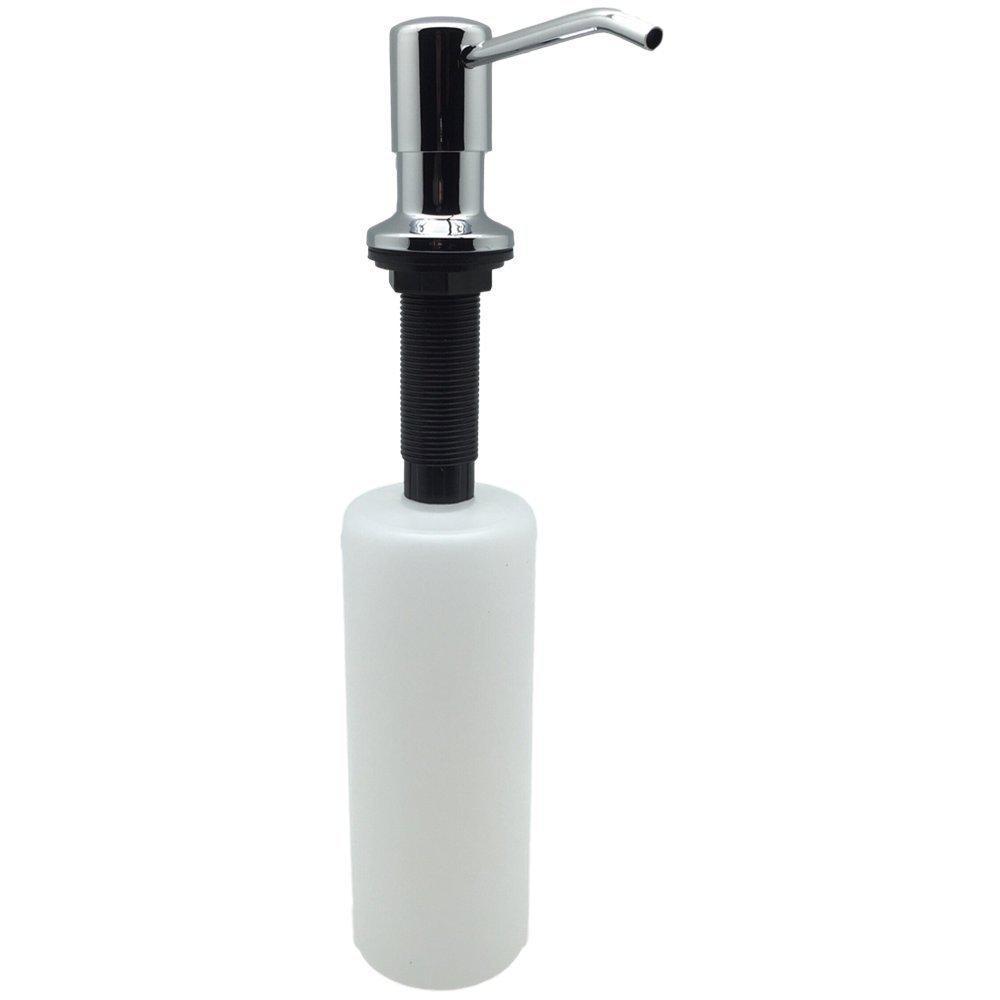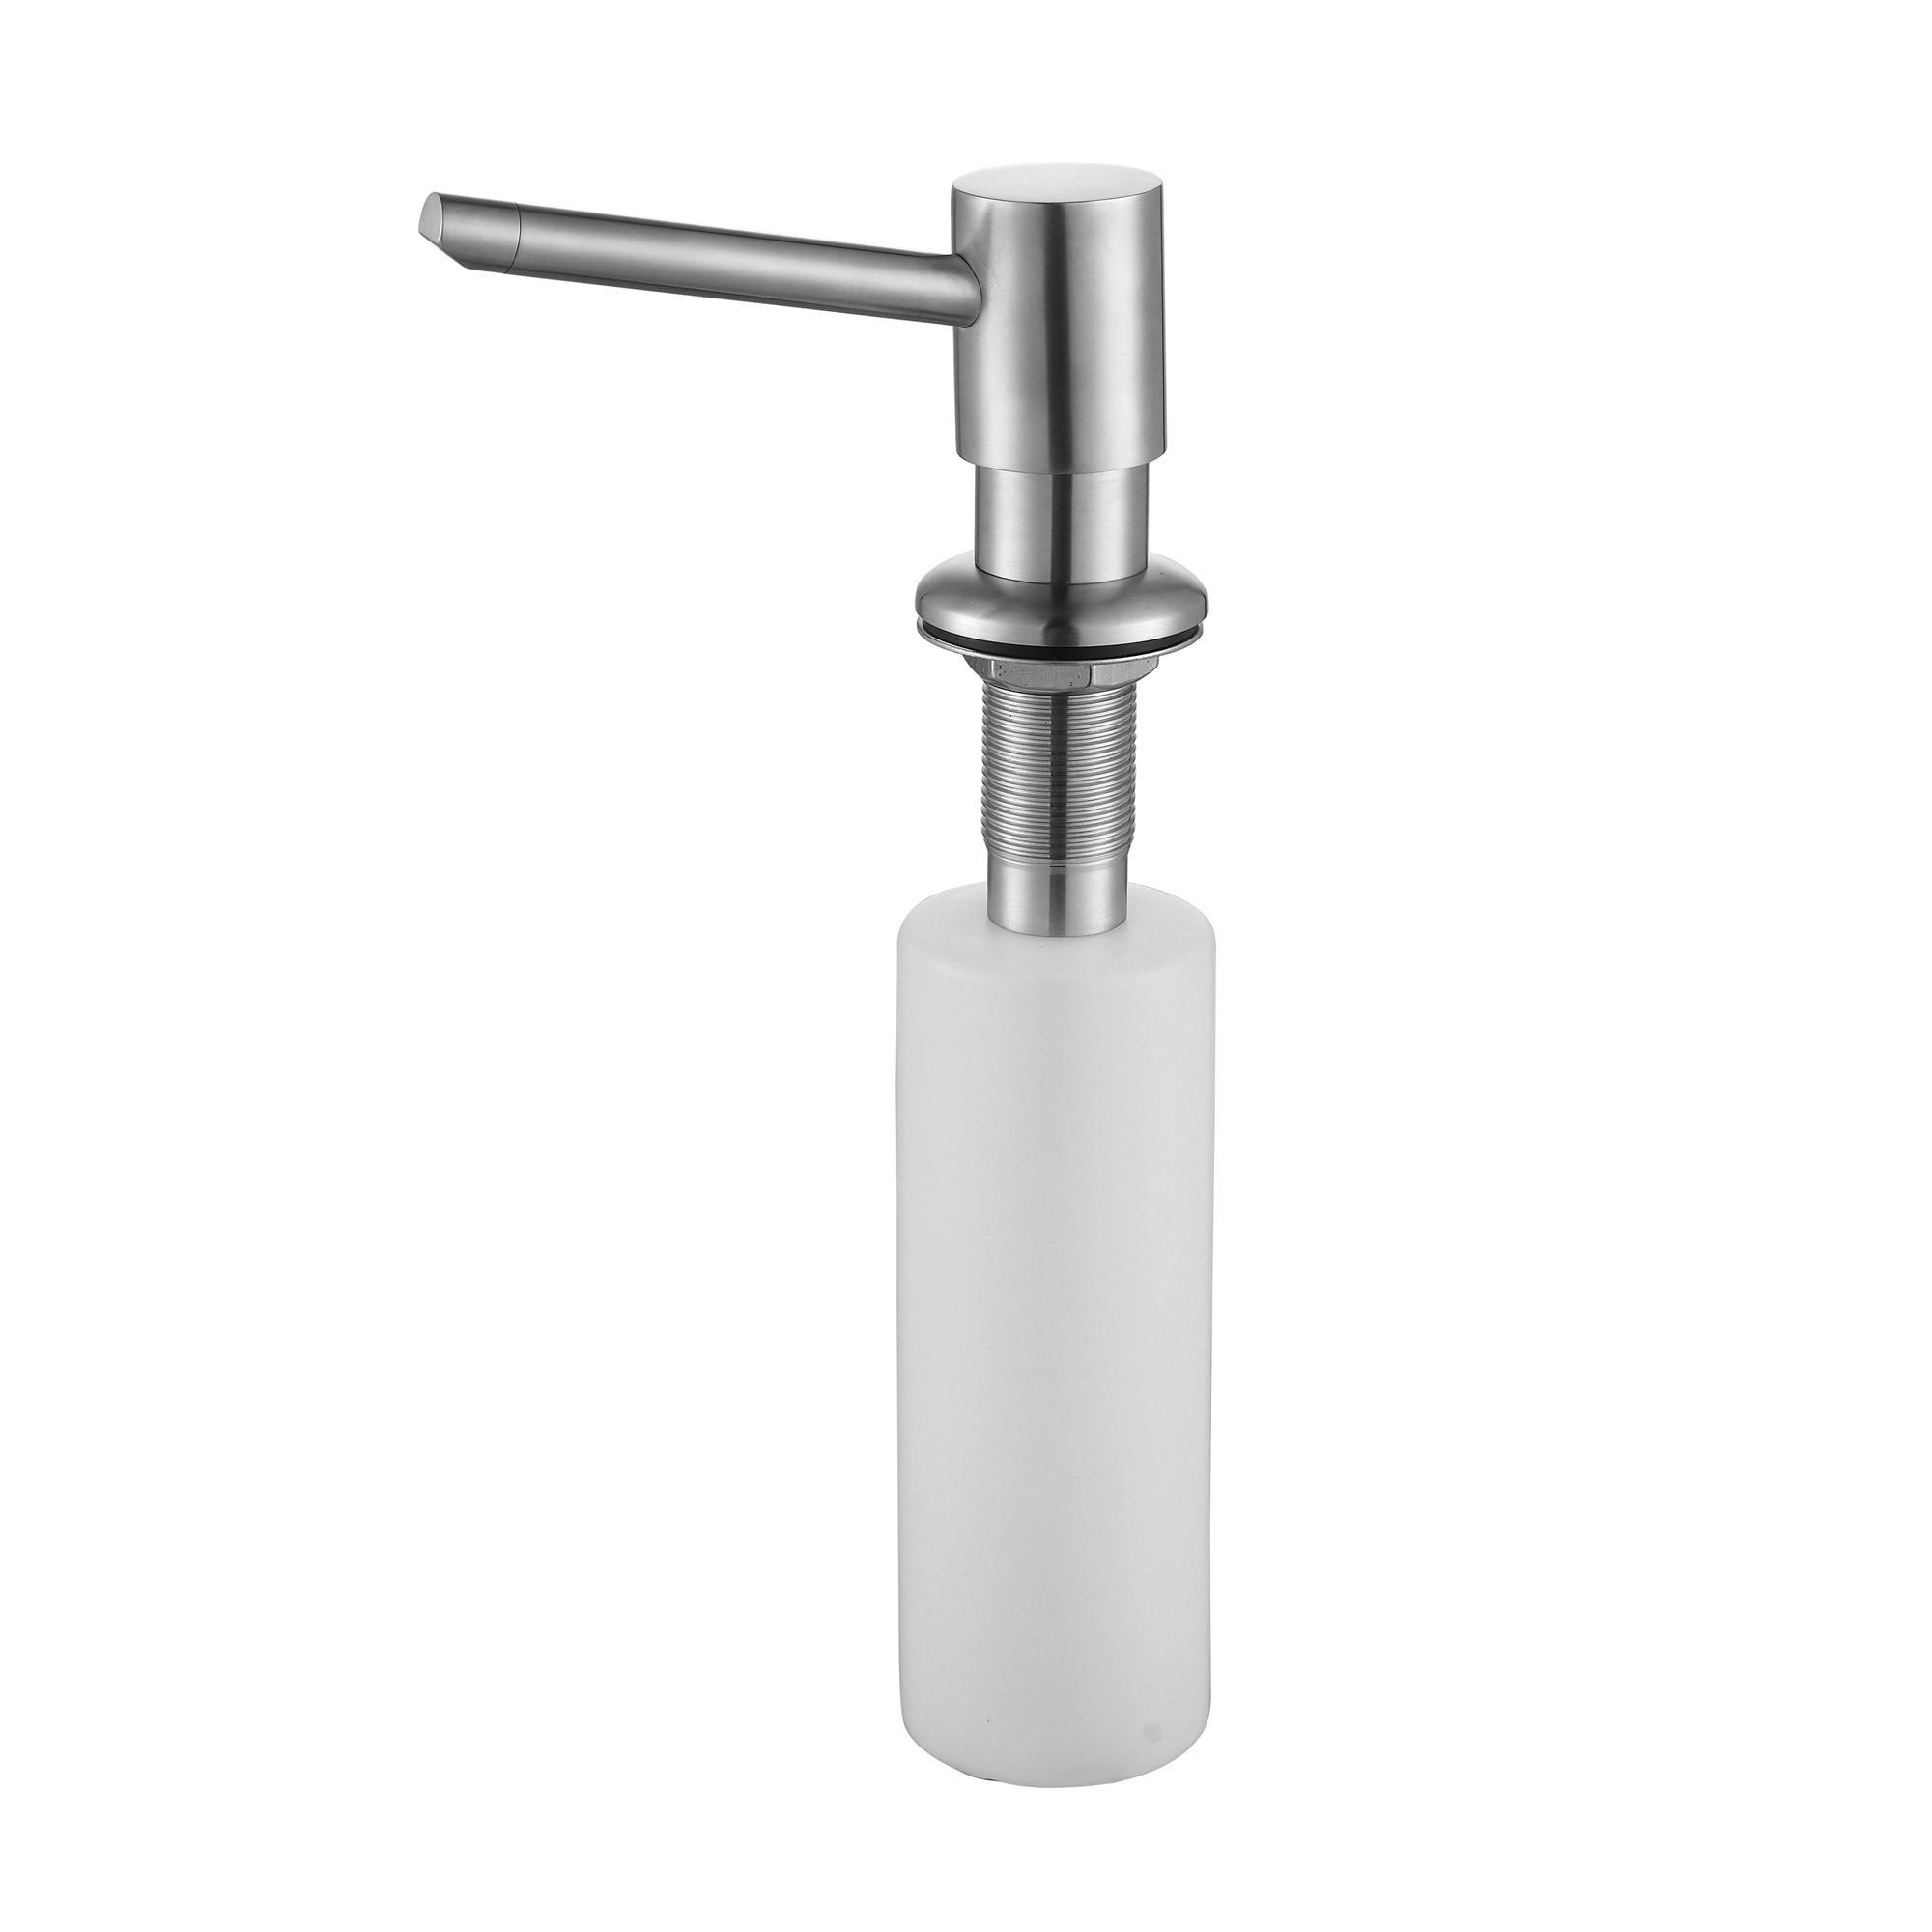The first image is the image on the left, the second image is the image on the right. Analyze the images presented: Is the assertion "The nozzles of the dispensers in the left and right images face generally toward each other." valid? Answer yes or no. Yes. The first image is the image on the left, the second image is the image on the right. Analyze the images presented: Is the assertion "The dispenser in the right photo has a transparent bottle." valid? Answer yes or no. No. 